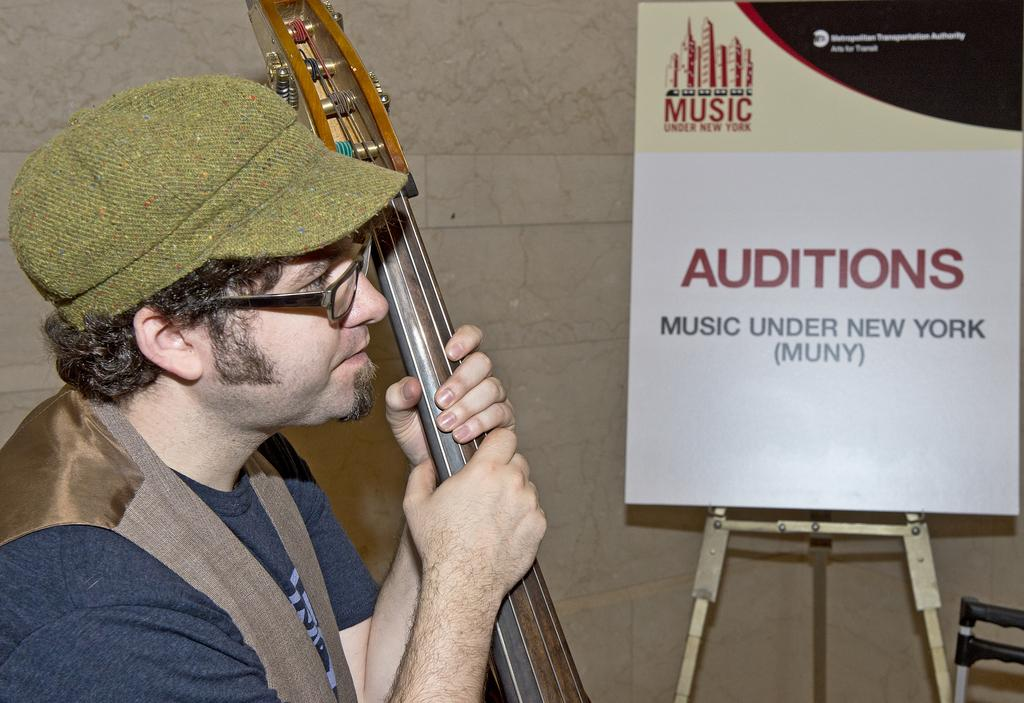What is the main subject of the image? There is a person in the image. What is the person holding in the image? The person is holding a musical instrument. Where is the musical instrument located in the image? The musical instrument is on the left side of the image. What else can be seen in the image besides the person and the musical instrument? There is a stand in the image. Where is the stand located in the image? The stand is on the right side of the image. What is written on the stand? There is text written on the stand. Can you see a snail crawling on the musical instrument in the image? No, there is no snail present in the image. What is the zinc content of the musical instrument in the image? The zinc content of the musical instrument cannot be determined from the image. 